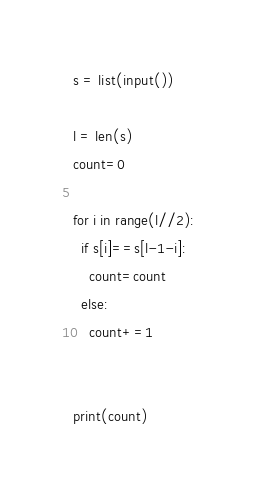<code> <loc_0><loc_0><loc_500><loc_500><_Python_>s = list(input())

l = len(s)
count=0

for i in range(l//2):
  if s[i]==s[l-1-i]:
    count=count
  else:
    count+=1


print(count)</code> 